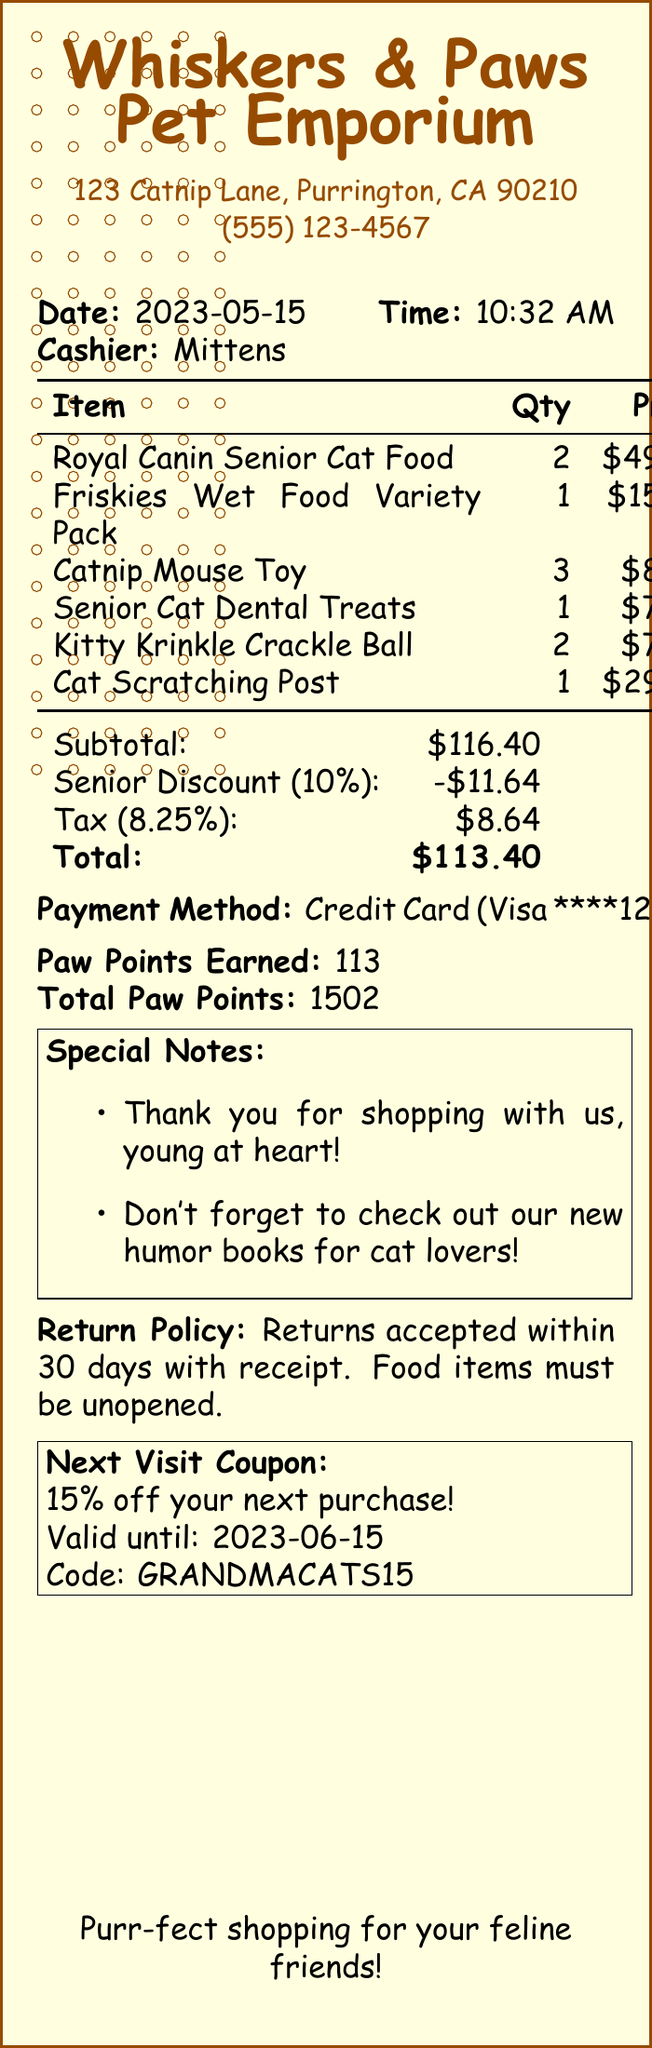What is the store name? The store name is found at the top of the receipt.
Answer: Whiskers & Paws Pet Emporium When was the purchase made? The date of purchase is listed in the document.
Answer: 2023-05-15 What is the total amount after the senior discount? The total amount is provided after subtracting the senior discount.
Answer: 113.40 How much was earned in Paw Points? The receipt states the number of Paw Points earned from the transaction.
Answer: 113 What is the percentage of the senior discount? This percentage is shown next to the discount amount in the document.
Answer: 10 What item had the highest price? The item prices are listed, and the highest can be determined from those.
Answer: Royal Canin Senior Cat Food What is the return policy for food items? Details about the return policy for food items are mentioned in the document.
Answer: Must be unopened What discount can be used on the next visit? The next visit discount is highlighted in the coupon section.
Answer: 15% off Who was the cashier? The name of the cashier is stated in the receipt details.
Answer: Mittens 